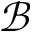<formula> <loc_0><loc_0><loc_500><loc_500>\mathcal { B }</formula> 